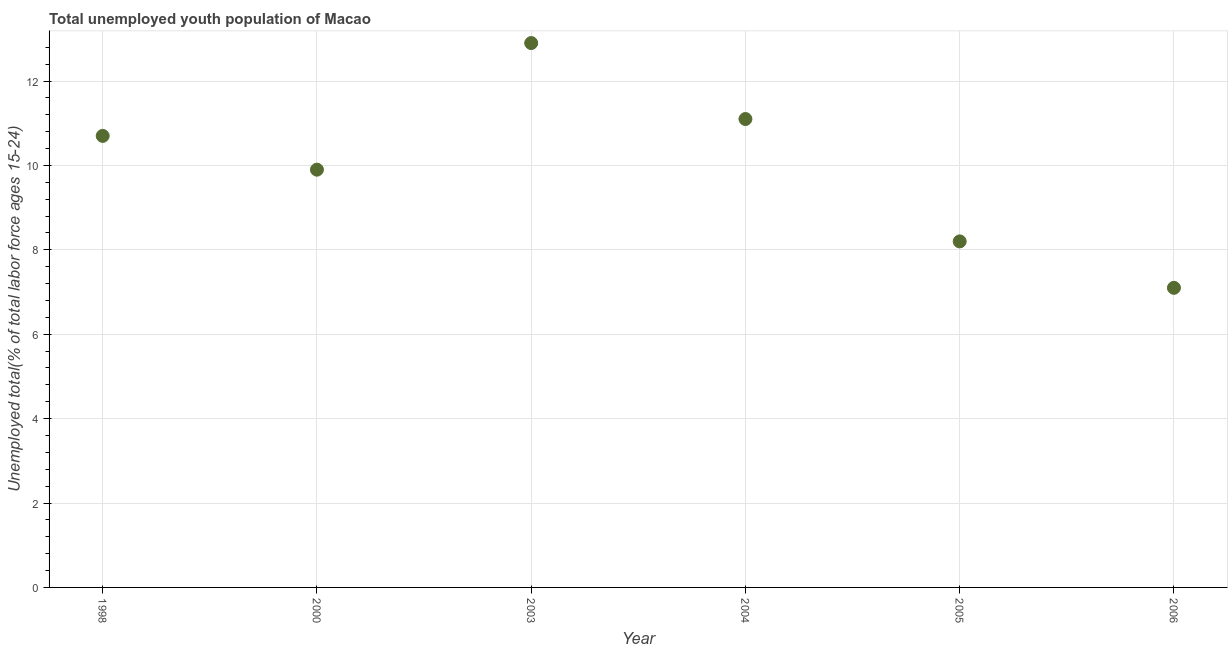What is the unemployed youth in 2005?
Make the answer very short. 8.2. Across all years, what is the maximum unemployed youth?
Offer a terse response. 12.9. Across all years, what is the minimum unemployed youth?
Keep it short and to the point. 7.1. In which year was the unemployed youth maximum?
Offer a terse response. 2003. What is the sum of the unemployed youth?
Your answer should be very brief. 59.9. What is the difference between the unemployed youth in 2004 and 2006?
Your response must be concise. 4. What is the average unemployed youth per year?
Offer a terse response. 9.98. What is the median unemployed youth?
Give a very brief answer. 10.3. Do a majority of the years between 2006 and 2003 (inclusive) have unemployed youth greater than 1.2000000000000002 %?
Your answer should be very brief. Yes. What is the ratio of the unemployed youth in 2004 to that in 2006?
Your answer should be very brief. 1.56. What is the difference between the highest and the second highest unemployed youth?
Your response must be concise. 1.8. Is the sum of the unemployed youth in 2003 and 2006 greater than the maximum unemployed youth across all years?
Ensure brevity in your answer.  Yes. What is the difference between the highest and the lowest unemployed youth?
Provide a short and direct response. 5.8. In how many years, is the unemployed youth greater than the average unemployed youth taken over all years?
Your answer should be compact. 3. What is the difference between two consecutive major ticks on the Y-axis?
Give a very brief answer. 2. Are the values on the major ticks of Y-axis written in scientific E-notation?
Provide a succinct answer. No. Does the graph contain grids?
Provide a short and direct response. Yes. What is the title of the graph?
Give a very brief answer. Total unemployed youth population of Macao. What is the label or title of the Y-axis?
Your answer should be very brief. Unemployed total(% of total labor force ages 15-24). What is the Unemployed total(% of total labor force ages 15-24) in 1998?
Keep it short and to the point. 10.7. What is the Unemployed total(% of total labor force ages 15-24) in 2000?
Give a very brief answer. 9.9. What is the Unemployed total(% of total labor force ages 15-24) in 2003?
Provide a short and direct response. 12.9. What is the Unemployed total(% of total labor force ages 15-24) in 2004?
Your answer should be compact. 11.1. What is the Unemployed total(% of total labor force ages 15-24) in 2005?
Provide a succinct answer. 8.2. What is the Unemployed total(% of total labor force ages 15-24) in 2006?
Make the answer very short. 7.1. What is the difference between the Unemployed total(% of total labor force ages 15-24) in 1998 and 2000?
Provide a short and direct response. 0.8. What is the difference between the Unemployed total(% of total labor force ages 15-24) in 1998 and 2005?
Your response must be concise. 2.5. What is the difference between the Unemployed total(% of total labor force ages 15-24) in 2000 and 2003?
Ensure brevity in your answer.  -3. What is the difference between the Unemployed total(% of total labor force ages 15-24) in 2000 and 2004?
Make the answer very short. -1.2. What is the difference between the Unemployed total(% of total labor force ages 15-24) in 2000 and 2005?
Your answer should be very brief. 1.7. What is the difference between the Unemployed total(% of total labor force ages 15-24) in 2003 and 2004?
Ensure brevity in your answer.  1.8. What is the difference between the Unemployed total(% of total labor force ages 15-24) in 2003 and 2005?
Offer a terse response. 4.7. What is the difference between the Unemployed total(% of total labor force ages 15-24) in 2003 and 2006?
Your response must be concise. 5.8. What is the difference between the Unemployed total(% of total labor force ages 15-24) in 2004 and 2005?
Offer a very short reply. 2.9. What is the difference between the Unemployed total(% of total labor force ages 15-24) in 2004 and 2006?
Provide a short and direct response. 4. What is the difference between the Unemployed total(% of total labor force ages 15-24) in 2005 and 2006?
Your response must be concise. 1.1. What is the ratio of the Unemployed total(% of total labor force ages 15-24) in 1998 to that in 2000?
Offer a terse response. 1.08. What is the ratio of the Unemployed total(% of total labor force ages 15-24) in 1998 to that in 2003?
Ensure brevity in your answer.  0.83. What is the ratio of the Unemployed total(% of total labor force ages 15-24) in 1998 to that in 2004?
Provide a short and direct response. 0.96. What is the ratio of the Unemployed total(% of total labor force ages 15-24) in 1998 to that in 2005?
Give a very brief answer. 1.3. What is the ratio of the Unemployed total(% of total labor force ages 15-24) in 1998 to that in 2006?
Ensure brevity in your answer.  1.51. What is the ratio of the Unemployed total(% of total labor force ages 15-24) in 2000 to that in 2003?
Offer a terse response. 0.77. What is the ratio of the Unemployed total(% of total labor force ages 15-24) in 2000 to that in 2004?
Offer a very short reply. 0.89. What is the ratio of the Unemployed total(% of total labor force ages 15-24) in 2000 to that in 2005?
Ensure brevity in your answer.  1.21. What is the ratio of the Unemployed total(% of total labor force ages 15-24) in 2000 to that in 2006?
Make the answer very short. 1.39. What is the ratio of the Unemployed total(% of total labor force ages 15-24) in 2003 to that in 2004?
Your response must be concise. 1.16. What is the ratio of the Unemployed total(% of total labor force ages 15-24) in 2003 to that in 2005?
Offer a very short reply. 1.57. What is the ratio of the Unemployed total(% of total labor force ages 15-24) in 2003 to that in 2006?
Your answer should be compact. 1.82. What is the ratio of the Unemployed total(% of total labor force ages 15-24) in 2004 to that in 2005?
Offer a terse response. 1.35. What is the ratio of the Unemployed total(% of total labor force ages 15-24) in 2004 to that in 2006?
Keep it short and to the point. 1.56. What is the ratio of the Unemployed total(% of total labor force ages 15-24) in 2005 to that in 2006?
Your answer should be very brief. 1.16. 